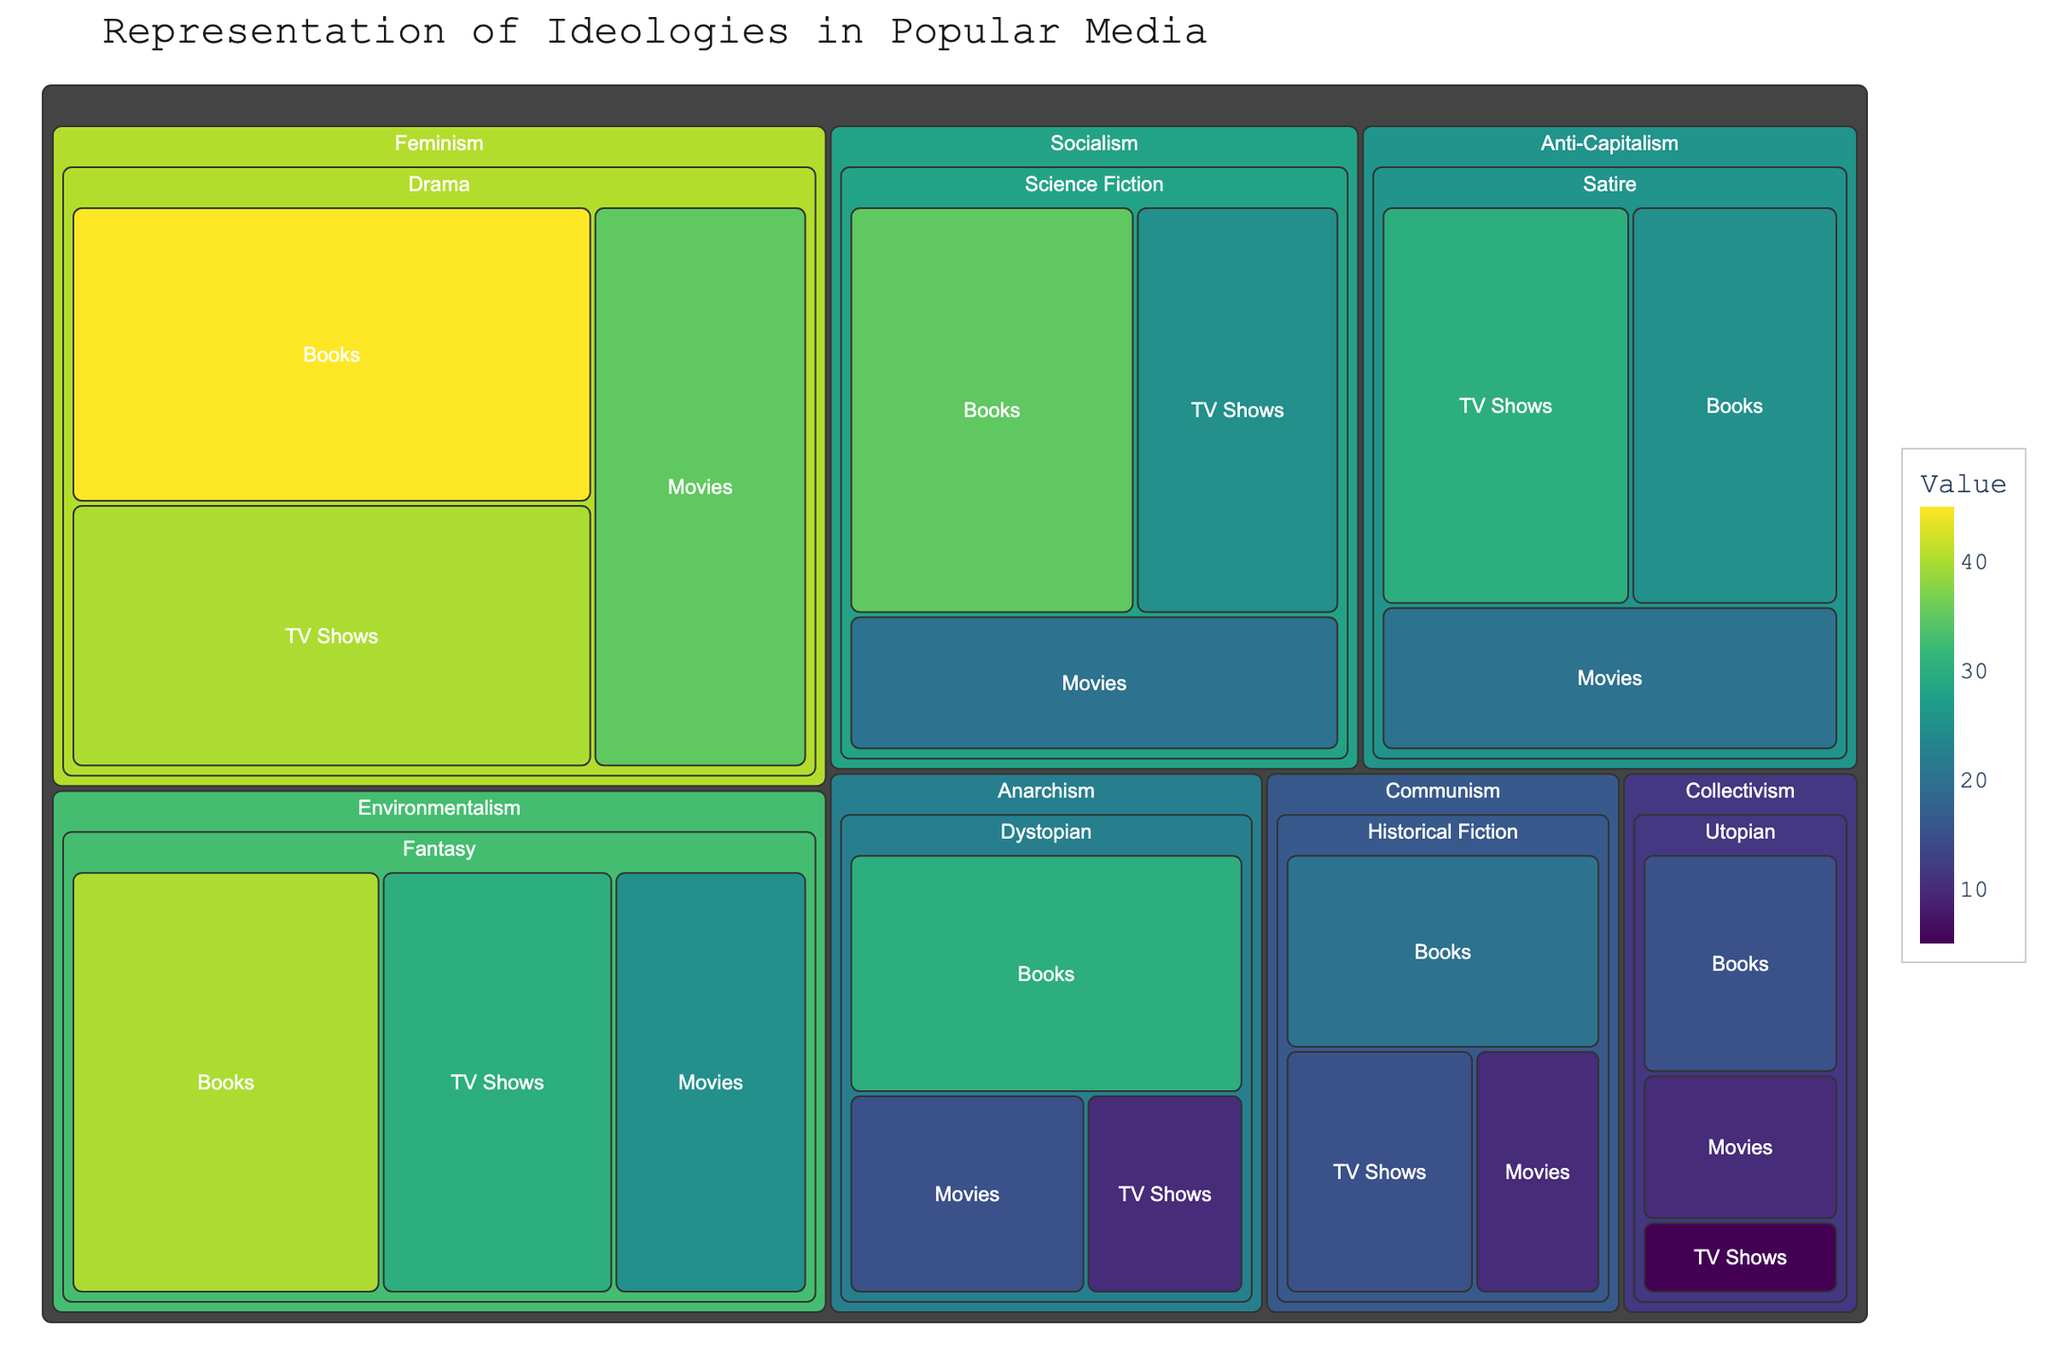What is the ideology with the highest representation in Drama genre? The plot shows different ideologies categorized by genre and medium. By examining the Drama genre, we see that Feminism has the highest representation with several books, movies, and TV shows.
Answer: Feminism Which genre has the least representation for the ideology of Collectivism? Looking at the treemap under the ideology of Collectivism, we can compare the values across different genres. The genre with the smallest representation value is TV Shows.
Answer: TV Shows How many total books represent Environmentalism in Fantasy? To find the total number of books, refer to the value for Environmentalism in the genre of Fantasy.
Answer: 40 What is the total representation for the ideology of Socialism across all mediums in Science Fiction? Add the values for Socialism in Science Fiction from Books, Movies, and TV Shows. These values are 35, 20, and 25 respectively. Hence, the total is 35+20+25.
Answer: 80 Between Anti-Capitalism in Books and Anarchism in Movies, which has a higher representation? Compare the value for Anti-Capitalism in Books (25) and Anarchism in Movies (15).
Answer: Anti-Capitalism in Books For Environmentalism in Fantasy, compare the representation in TV Shows vs. Movies. Which has higher value? Check the values for Environmentalism in Fantasy for both TV Shows (30) and Movies (25). Thus, TV Shows has a higher value.
Answer: TV Shows Does the value for Communism in Historical Fiction TV Shows exceed that for Utopian Collectivism in all mediums? First, get the value for Utopian Collectivism in TV Shows, Movies, and Books (5, 10, and 15 respectively) and sum them up to get 30. Compare it with the value for Historical Fiction TV Shows (15). The value for Communism TV Shows does not exceed the sum of Utopian Collectivism.
Answer: No What is the most represented ideology in the Science Fiction genre on TV Shows? Examine the values under the Science Fiction genre for TV Shows. The highest value listed is for Socialism.
Answer: Socialism Can you rank the ideologies based on their total representation in Books medium from highest to lowest? Sum the values for each ideology in the Books medium: Feminism (45), Environmentalism (40), Socialism (35), Anarchism (30), Anti-Capitalism (25), Communism (20), Collectivism (15). Ranking them, we get: Feminism > Environmentalism > Socialism > Anarchism > Anti-Capitalism > Communism > Collectivism.
Answer: Feminism, Environmentalism, Socialism, Anarchism, Anti-Capitalism, Communism, Collectivism 